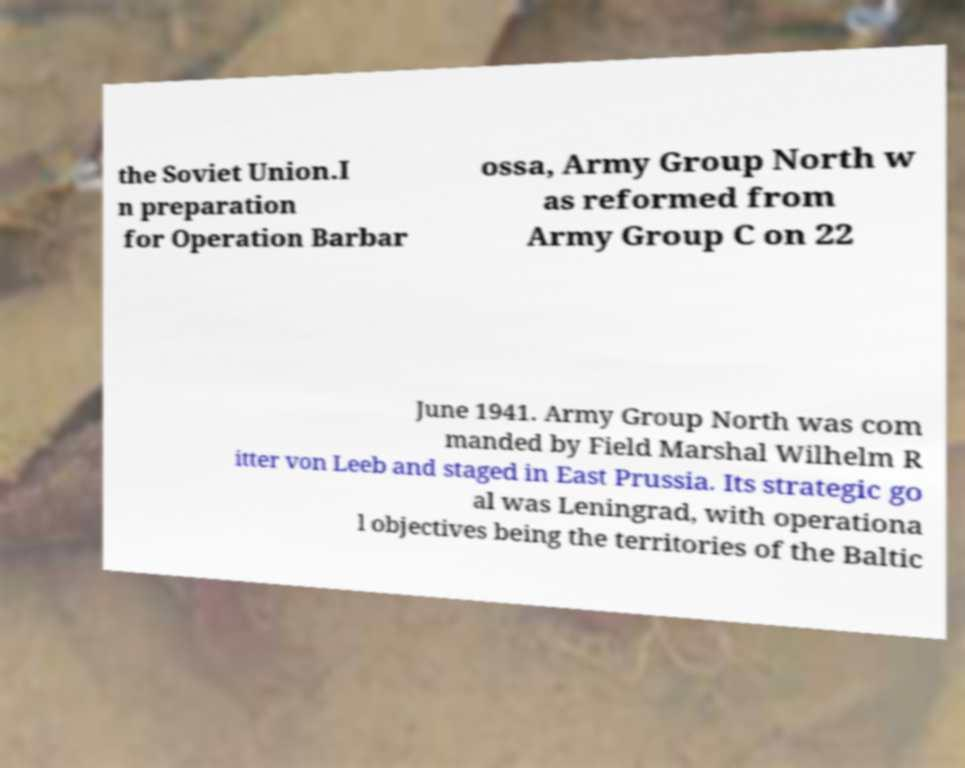For documentation purposes, I need the text within this image transcribed. Could you provide that? the Soviet Union.I n preparation for Operation Barbar ossa, Army Group North w as reformed from Army Group C on 22 June 1941. Army Group North was com manded by Field Marshal Wilhelm R itter von Leeb and staged in East Prussia. Its strategic go al was Leningrad, with operationa l objectives being the territories of the Baltic 